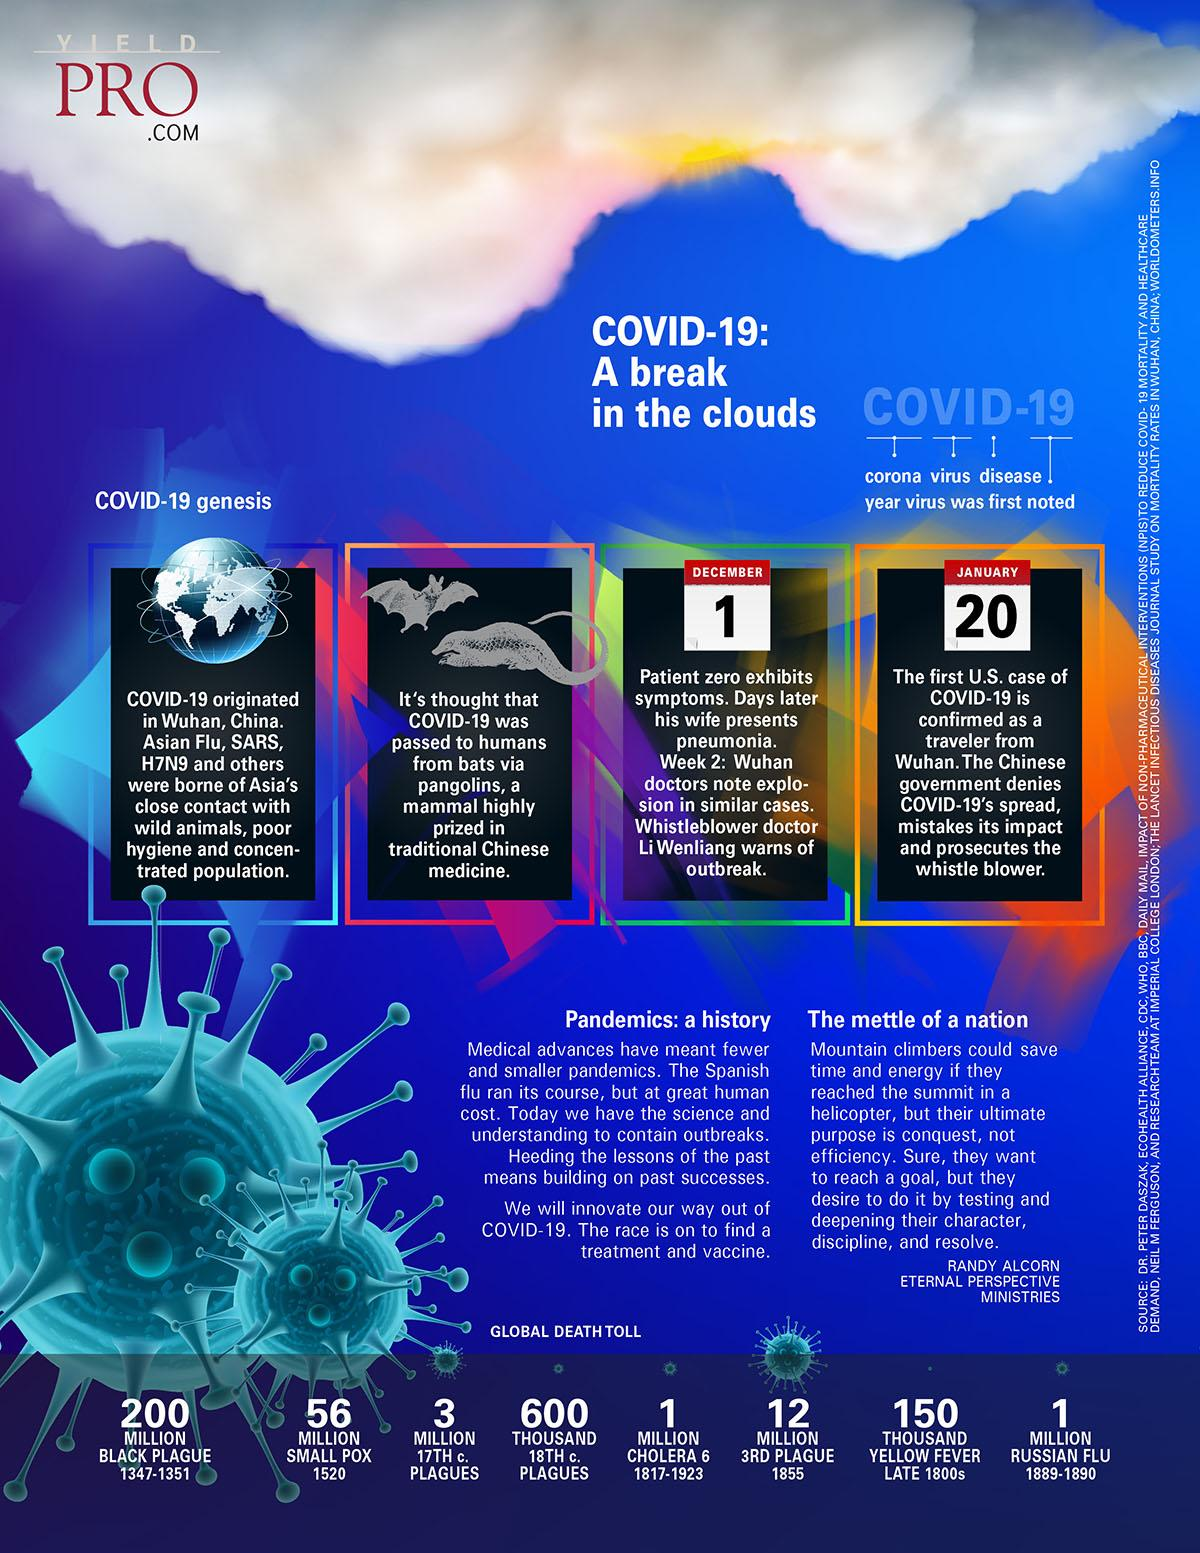Indicate a few pertinent items in this graphic. The third plague pandemic started in 1855. It is estimated that 3 million people were killed by the 17th century plague. The two animals believed to be the source of the COVID-19 virus in China are bats and pangolins. The smallpox epidemic began in 1520. On December 31, 2019, the first confirmed case of COVID-19 was detected in Wuhan, China, marking the beginning of the global pandemic. 